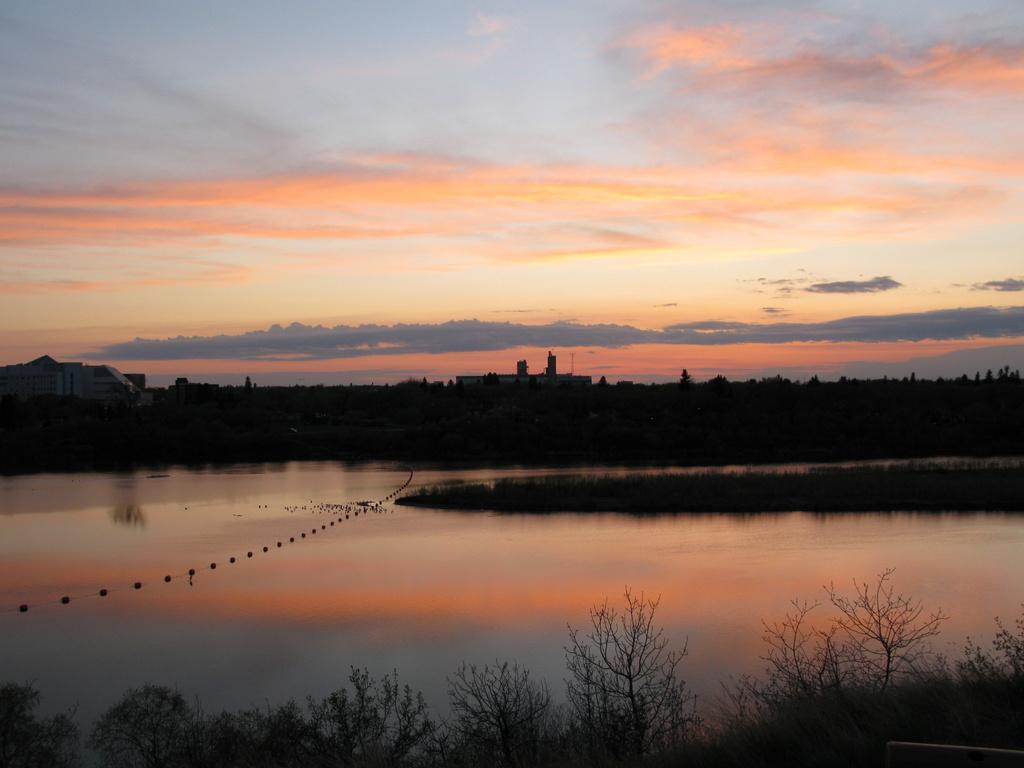Could you give a brief overview of what you see in this image? In the image in the center, we can see the sky, clouds, trees, water etc. 